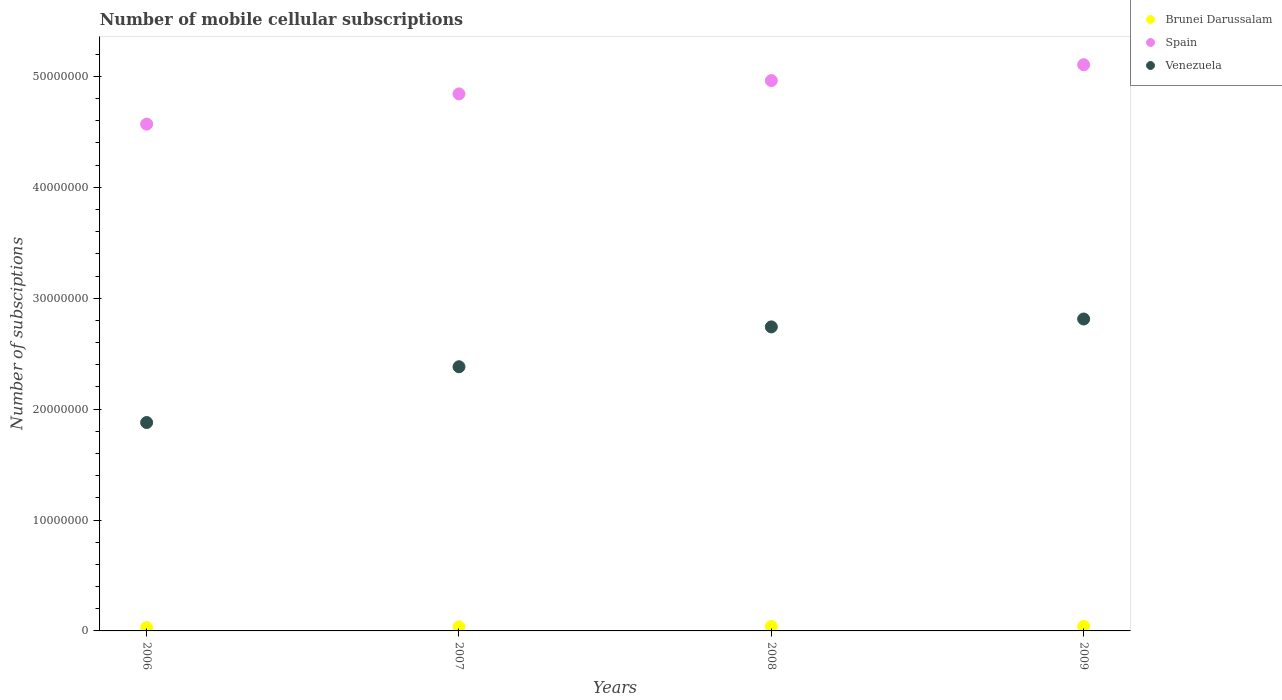How many different coloured dotlines are there?
Provide a short and direct response. 3. Is the number of dotlines equal to the number of legend labels?
Your response must be concise. Yes. What is the number of mobile cellular subscriptions in Venezuela in 2006?
Give a very brief answer. 1.88e+07. Across all years, what is the maximum number of mobile cellular subscriptions in Brunei Darussalam?
Your response must be concise. 4.13e+05. Across all years, what is the minimum number of mobile cellular subscriptions in Brunei Darussalam?
Your answer should be compact. 3.01e+05. In which year was the number of mobile cellular subscriptions in Spain maximum?
Your answer should be compact. 2009. In which year was the number of mobile cellular subscriptions in Brunei Darussalam minimum?
Your answer should be very brief. 2006. What is the total number of mobile cellular subscriptions in Brunei Darussalam in the graph?
Provide a succinct answer. 1.48e+06. What is the difference between the number of mobile cellular subscriptions in Spain in 2006 and that in 2007?
Your response must be concise. -2.73e+06. What is the difference between the number of mobile cellular subscriptions in Spain in 2006 and the number of mobile cellular subscriptions in Venezuela in 2009?
Give a very brief answer. 1.76e+07. What is the average number of mobile cellular subscriptions in Brunei Darussalam per year?
Give a very brief answer. 3.70e+05. In the year 2009, what is the difference between the number of mobile cellular subscriptions in Spain and number of mobile cellular subscriptions in Venezuela?
Keep it short and to the point. 2.29e+07. In how many years, is the number of mobile cellular subscriptions in Venezuela greater than 38000000?
Keep it short and to the point. 0. What is the ratio of the number of mobile cellular subscriptions in Spain in 2006 to that in 2008?
Provide a short and direct response. 0.92. What is the difference between the highest and the second highest number of mobile cellular subscriptions in Venezuela?
Provide a succinct answer. 7.09e+05. What is the difference between the highest and the lowest number of mobile cellular subscriptions in Venezuela?
Your response must be concise. 9.33e+06. Is the sum of the number of mobile cellular subscriptions in Spain in 2007 and 2009 greater than the maximum number of mobile cellular subscriptions in Venezuela across all years?
Your answer should be compact. Yes. Is the number of mobile cellular subscriptions in Venezuela strictly less than the number of mobile cellular subscriptions in Spain over the years?
Offer a very short reply. Yes. How many dotlines are there?
Offer a terse response. 3. How many years are there in the graph?
Offer a very short reply. 4. What is the difference between two consecutive major ticks on the Y-axis?
Your answer should be compact. 1.00e+07. Are the values on the major ticks of Y-axis written in scientific E-notation?
Keep it short and to the point. No. Does the graph contain any zero values?
Offer a terse response. No. Does the graph contain grids?
Offer a very short reply. No. How are the legend labels stacked?
Ensure brevity in your answer.  Vertical. What is the title of the graph?
Keep it short and to the point. Number of mobile cellular subscriptions. What is the label or title of the X-axis?
Make the answer very short. Years. What is the label or title of the Y-axis?
Make the answer very short. Number of subsciptions. What is the Number of subsciptions in Brunei Darussalam in 2006?
Keep it short and to the point. 3.01e+05. What is the Number of subsciptions in Spain in 2006?
Your answer should be compact. 4.57e+07. What is the Number of subsciptions in Venezuela in 2006?
Keep it short and to the point. 1.88e+07. What is the Number of subsciptions in Brunei Darussalam in 2007?
Your response must be concise. 3.66e+05. What is the Number of subsciptions in Spain in 2007?
Your answer should be very brief. 4.84e+07. What is the Number of subsciptions of Venezuela in 2007?
Give a very brief answer. 2.38e+07. What is the Number of subsciptions of Brunei Darussalam in 2008?
Your answer should be compact. 3.99e+05. What is the Number of subsciptions in Spain in 2008?
Your answer should be compact. 4.96e+07. What is the Number of subsciptions of Venezuela in 2008?
Provide a succinct answer. 2.74e+07. What is the Number of subsciptions in Brunei Darussalam in 2009?
Give a very brief answer. 4.13e+05. What is the Number of subsciptions in Spain in 2009?
Keep it short and to the point. 5.11e+07. What is the Number of subsciptions in Venezuela in 2009?
Make the answer very short. 2.81e+07. Across all years, what is the maximum Number of subsciptions in Brunei Darussalam?
Ensure brevity in your answer.  4.13e+05. Across all years, what is the maximum Number of subsciptions of Spain?
Give a very brief answer. 5.11e+07. Across all years, what is the maximum Number of subsciptions of Venezuela?
Offer a very short reply. 2.81e+07. Across all years, what is the minimum Number of subsciptions of Brunei Darussalam?
Provide a succinct answer. 3.01e+05. Across all years, what is the minimum Number of subsciptions of Spain?
Your answer should be compact. 4.57e+07. Across all years, what is the minimum Number of subsciptions of Venezuela?
Provide a succinct answer. 1.88e+07. What is the total Number of subsciptions of Brunei Darussalam in the graph?
Provide a short and direct response. 1.48e+06. What is the total Number of subsciptions of Spain in the graph?
Keep it short and to the point. 1.95e+08. What is the total Number of subsciptions in Venezuela in the graph?
Give a very brief answer. 9.81e+07. What is the difference between the Number of subsciptions of Brunei Darussalam in 2006 and that in 2007?
Offer a terse response. -6.47e+04. What is the difference between the Number of subsciptions of Spain in 2006 and that in 2007?
Keep it short and to the point. -2.73e+06. What is the difference between the Number of subsciptions in Venezuela in 2006 and that in 2007?
Offer a very short reply. -5.03e+06. What is the difference between the Number of subsciptions of Brunei Darussalam in 2006 and that in 2008?
Your answer should be very brief. -9.75e+04. What is the difference between the Number of subsciptions of Spain in 2006 and that in 2008?
Make the answer very short. -3.93e+06. What is the difference between the Number of subsciptions of Venezuela in 2006 and that in 2008?
Provide a short and direct response. -8.62e+06. What is the difference between the Number of subsciptions of Brunei Darussalam in 2006 and that in 2009?
Keep it short and to the point. -1.11e+05. What is the difference between the Number of subsciptions of Spain in 2006 and that in 2009?
Provide a short and direct response. -5.36e+06. What is the difference between the Number of subsciptions in Venezuela in 2006 and that in 2009?
Your answer should be very brief. -9.33e+06. What is the difference between the Number of subsciptions in Brunei Darussalam in 2007 and that in 2008?
Offer a terse response. -3.27e+04. What is the difference between the Number of subsciptions of Spain in 2007 and that in 2008?
Give a very brief answer. -1.20e+06. What is the difference between the Number of subsciptions of Venezuela in 2007 and that in 2008?
Ensure brevity in your answer.  -3.59e+06. What is the difference between the Number of subsciptions in Brunei Darussalam in 2007 and that in 2009?
Make the answer very short. -4.67e+04. What is the difference between the Number of subsciptions of Spain in 2007 and that in 2009?
Your response must be concise. -2.63e+06. What is the difference between the Number of subsciptions of Venezuela in 2007 and that in 2009?
Offer a very short reply. -4.30e+06. What is the difference between the Number of subsciptions in Brunei Darussalam in 2008 and that in 2009?
Offer a terse response. -1.40e+04. What is the difference between the Number of subsciptions in Spain in 2008 and that in 2009?
Provide a short and direct response. -1.43e+06. What is the difference between the Number of subsciptions of Venezuela in 2008 and that in 2009?
Offer a terse response. -7.09e+05. What is the difference between the Number of subsciptions in Brunei Darussalam in 2006 and the Number of subsciptions in Spain in 2007?
Give a very brief answer. -4.81e+07. What is the difference between the Number of subsciptions of Brunei Darussalam in 2006 and the Number of subsciptions of Venezuela in 2007?
Ensure brevity in your answer.  -2.35e+07. What is the difference between the Number of subsciptions of Spain in 2006 and the Number of subsciptions of Venezuela in 2007?
Your answer should be very brief. 2.19e+07. What is the difference between the Number of subsciptions in Brunei Darussalam in 2006 and the Number of subsciptions in Spain in 2008?
Provide a succinct answer. -4.93e+07. What is the difference between the Number of subsciptions of Brunei Darussalam in 2006 and the Number of subsciptions of Venezuela in 2008?
Make the answer very short. -2.71e+07. What is the difference between the Number of subsciptions of Spain in 2006 and the Number of subsciptions of Venezuela in 2008?
Offer a terse response. 1.83e+07. What is the difference between the Number of subsciptions in Brunei Darussalam in 2006 and the Number of subsciptions in Spain in 2009?
Keep it short and to the point. -5.08e+07. What is the difference between the Number of subsciptions in Brunei Darussalam in 2006 and the Number of subsciptions in Venezuela in 2009?
Your response must be concise. -2.78e+07. What is the difference between the Number of subsciptions in Spain in 2006 and the Number of subsciptions in Venezuela in 2009?
Give a very brief answer. 1.76e+07. What is the difference between the Number of subsciptions of Brunei Darussalam in 2007 and the Number of subsciptions of Spain in 2008?
Make the answer very short. -4.93e+07. What is the difference between the Number of subsciptions of Brunei Darussalam in 2007 and the Number of subsciptions of Venezuela in 2008?
Your response must be concise. -2.70e+07. What is the difference between the Number of subsciptions in Spain in 2007 and the Number of subsciptions in Venezuela in 2008?
Ensure brevity in your answer.  2.10e+07. What is the difference between the Number of subsciptions in Brunei Darussalam in 2007 and the Number of subsciptions in Spain in 2009?
Keep it short and to the point. -5.07e+07. What is the difference between the Number of subsciptions in Brunei Darussalam in 2007 and the Number of subsciptions in Venezuela in 2009?
Your answer should be very brief. -2.78e+07. What is the difference between the Number of subsciptions in Spain in 2007 and the Number of subsciptions in Venezuela in 2009?
Keep it short and to the point. 2.03e+07. What is the difference between the Number of subsciptions in Brunei Darussalam in 2008 and the Number of subsciptions in Spain in 2009?
Provide a succinct answer. -5.07e+07. What is the difference between the Number of subsciptions of Brunei Darussalam in 2008 and the Number of subsciptions of Venezuela in 2009?
Provide a short and direct response. -2.77e+07. What is the difference between the Number of subsciptions in Spain in 2008 and the Number of subsciptions in Venezuela in 2009?
Ensure brevity in your answer.  2.15e+07. What is the average Number of subsciptions in Brunei Darussalam per year?
Make the answer very short. 3.70e+05. What is the average Number of subsciptions in Spain per year?
Your answer should be compact. 4.87e+07. What is the average Number of subsciptions of Venezuela per year?
Keep it short and to the point. 2.45e+07. In the year 2006, what is the difference between the Number of subsciptions of Brunei Darussalam and Number of subsciptions of Spain?
Your answer should be compact. -4.54e+07. In the year 2006, what is the difference between the Number of subsciptions in Brunei Darussalam and Number of subsciptions in Venezuela?
Keep it short and to the point. -1.85e+07. In the year 2006, what is the difference between the Number of subsciptions in Spain and Number of subsciptions in Venezuela?
Your answer should be very brief. 2.69e+07. In the year 2007, what is the difference between the Number of subsciptions in Brunei Darussalam and Number of subsciptions in Spain?
Your answer should be very brief. -4.81e+07. In the year 2007, what is the difference between the Number of subsciptions of Brunei Darussalam and Number of subsciptions of Venezuela?
Your answer should be very brief. -2.35e+07. In the year 2007, what is the difference between the Number of subsciptions in Spain and Number of subsciptions in Venezuela?
Make the answer very short. 2.46e+07. In the year 2008, what is the difference between the Number of subsciptions in Brunei Darussalam and Number of subsciptions in Spain?
Make the answer very short. -4.92e+07. In the year 2008, what is the difference between the Number of subsciptions in Brunei Darussalam and Number of subsciptions in Venezuela?
Make the answer very short. -2.70e+07. In the year 2008, what is the difference between the Number of subsciptions of Spain and Number of subsciptions of Venezuela?
Your answer should be compact. 2.22e+07. In the year 2009, what is the difference between the Number of subsciptions of Brunei Darussalam and Number of subsciptions of Spain?
Your answer should be compact. -5.06e+07. In the year 2009, what is the difference between the Number of subsciptions in Brunei Darussalam and Number of subsciptions in Venezuela?
Give a very brief answer. -2.77e+07. In the year 2009, what is the difference between the Number of subsciptions in Spain and Number of subsciptions in Venezuela?
Offer a terse response. 2.29e+07. What is the ratio of the Number of subsciptions in Brunei Darussalam in 2006 to that in 2007?
Give a very brief answer. 0.82. What is the ratio of the Number of subsciptions in Spain in 2006 to that in 2007?
Give a very brief answer. 0.94. What is the ratio of the Number of subsciptions of Venezuela in 2006 to that in 2007?
Ensure brevity in your answer.  0.79. What is the ratio of the Number of subsciptions of Brunei Darussalam in 2006 to that in 2008?
Ensure brevity in your answer.  0.76. What is the ratio of the Number of subsciptions in Spain in 2006 to that in 2008?
Your answer should be compact. 0.92. What is the ratio of the Number of subsciptions in Venezuela in 2006 to that in 2008?
Ensure brevity in your answer.  0.69. What is the ratio of the Number of subsciptions of Brunei Darussalam in 2006 to that in 2009?
Your response must be concise. 0.73. What is the ratio of the Number of subsciptions of Spain in 2006 to that in 2009?
Your answer should be very brief. 0.9. What is the ratio of the Number of subsciptions of Venezuela in 2006 to that in 2009?
Your answer should be compact. 0.67. What is the ratio of the Number of subsciptions in Brunei Darussalam in 2007 to that in 2008?
Offer a terse response. 0.92. What is the ratio of the Number of subsciptions of Spain in 2007 to that in 2008?
Keep it short and to the point. 0.98. What is the ratio of the Number of subsciptions in Venezuela in 2007 to that in 2008?
Offer a very short reply. 0.87. What is the ratio of the Number of subsciptions in Brunei Darussalam in 2007 to that in 2009?
Offer a very short reply. 0.89. What is the ratio of the Number of subsciptions in Spain in 2007 to that in 2009?
Ensure brevity in your answer.  0.95. What is the ratio of the Number of subsciptions of Venezuela in 2007 to that in 2009?
Your response must be concise. 0.85. What is the ratio of the Number of subsciptions in Spain in 2008 to that in 2009?
Your response must be concise. 0.97. What is the ratio of the Number of subsciptions of Venezuela in 2008 to that in 2009?
Your response must be concise. 0.97. What is the difference between the highest and the second highest Number of subsciptions in Brunei Darussalam?
Provide a short and direct response. 1.40e+04. What is the difference between the highest and the second highest Number of subsciptions in Spain?
Provide a short and direct response. 1.43e+06. What is the difference between the highest and the second highest Number of subsciptions of Venezuela?
Offer a very short reply. 7.09e+05. What is the difference between the highest and the lowest Number of subsciptions of Brunei Darussalam?
Give a very brief answer. 1.11e+05. What is the difference between the highest and the lowest Number of subsciptions in Spain?
Your answer should be very brief. 5.36e+06. What is the difference between the highest and the lowest Number of subsciptions of Venezuela?
Make the answer very short. 9.33e+06. 